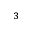<formula> <loc_0><loc_0><loc_500><loc_500>^ { 3 }</formula> 